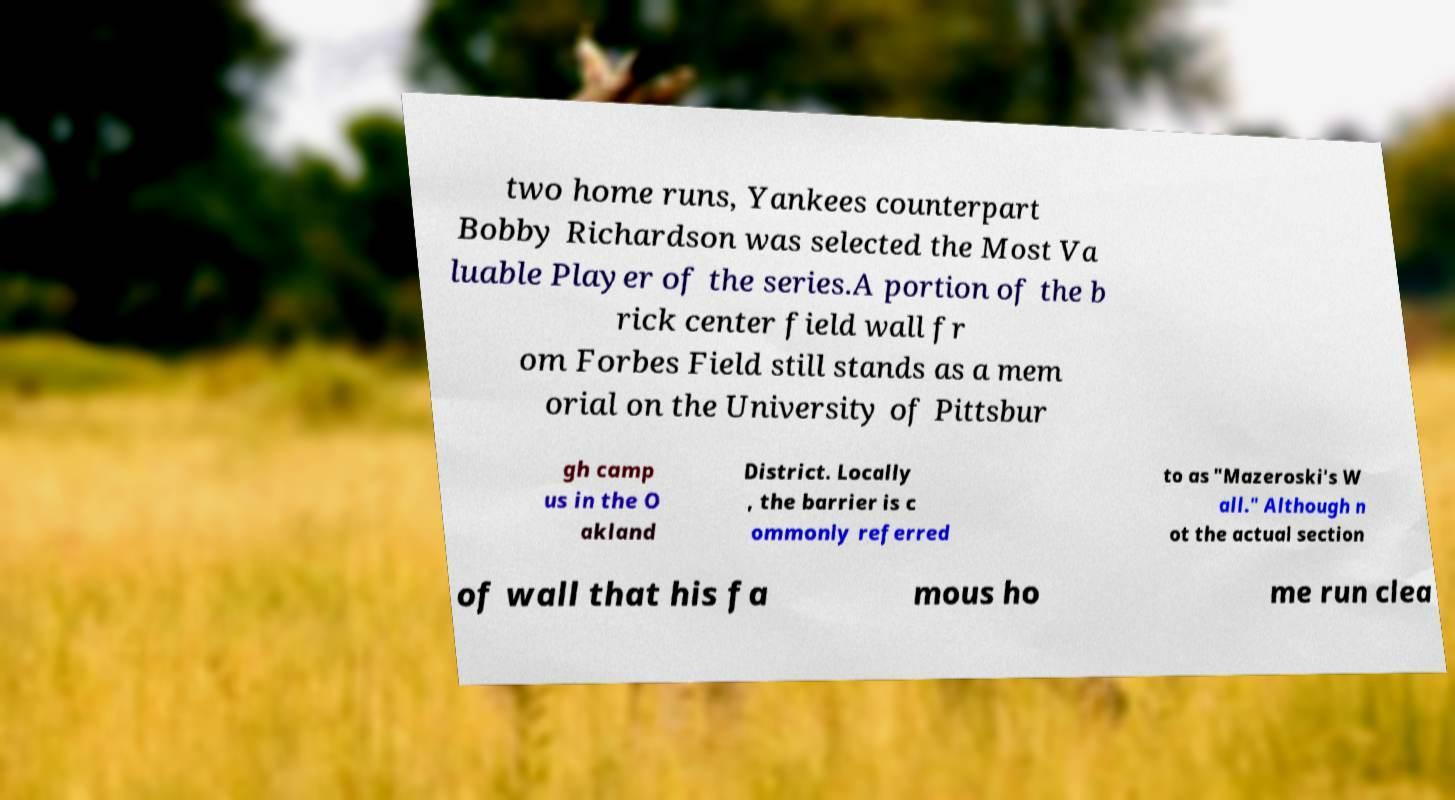Can you accurately transcribe the text from the provided image for me? two home runs, Yankees counterpart Bobby Richardson was selected the Most Va luable Player of the series.A portion of the b rick center field wall fr om Forbes Field still stands as a mem orial on the University of Pittsbur gh camp us in the O akland District. Locally , the barrier is c ommonly referred to as "Mazeroski's W all." Although n ot the actual section of wall that his fa mous ho me run clea 